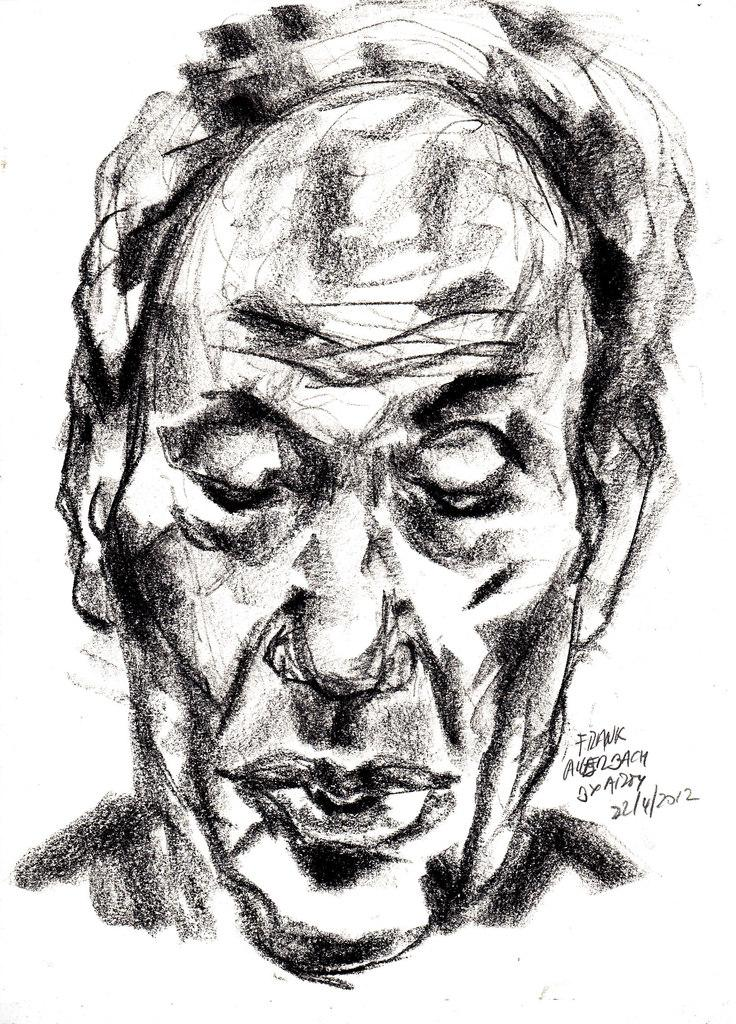What is the main subject of the image? The main subject of the image is a drawing of a person's face. What else can be seen in the image besides the drawing? There is text in the image. What type of education is being taught in the image? There is no indication of education being taught in the image; it primarily features a drawing of a person's face and text. How many basketballs are visible in the image? There are no basketballs present in the image. 